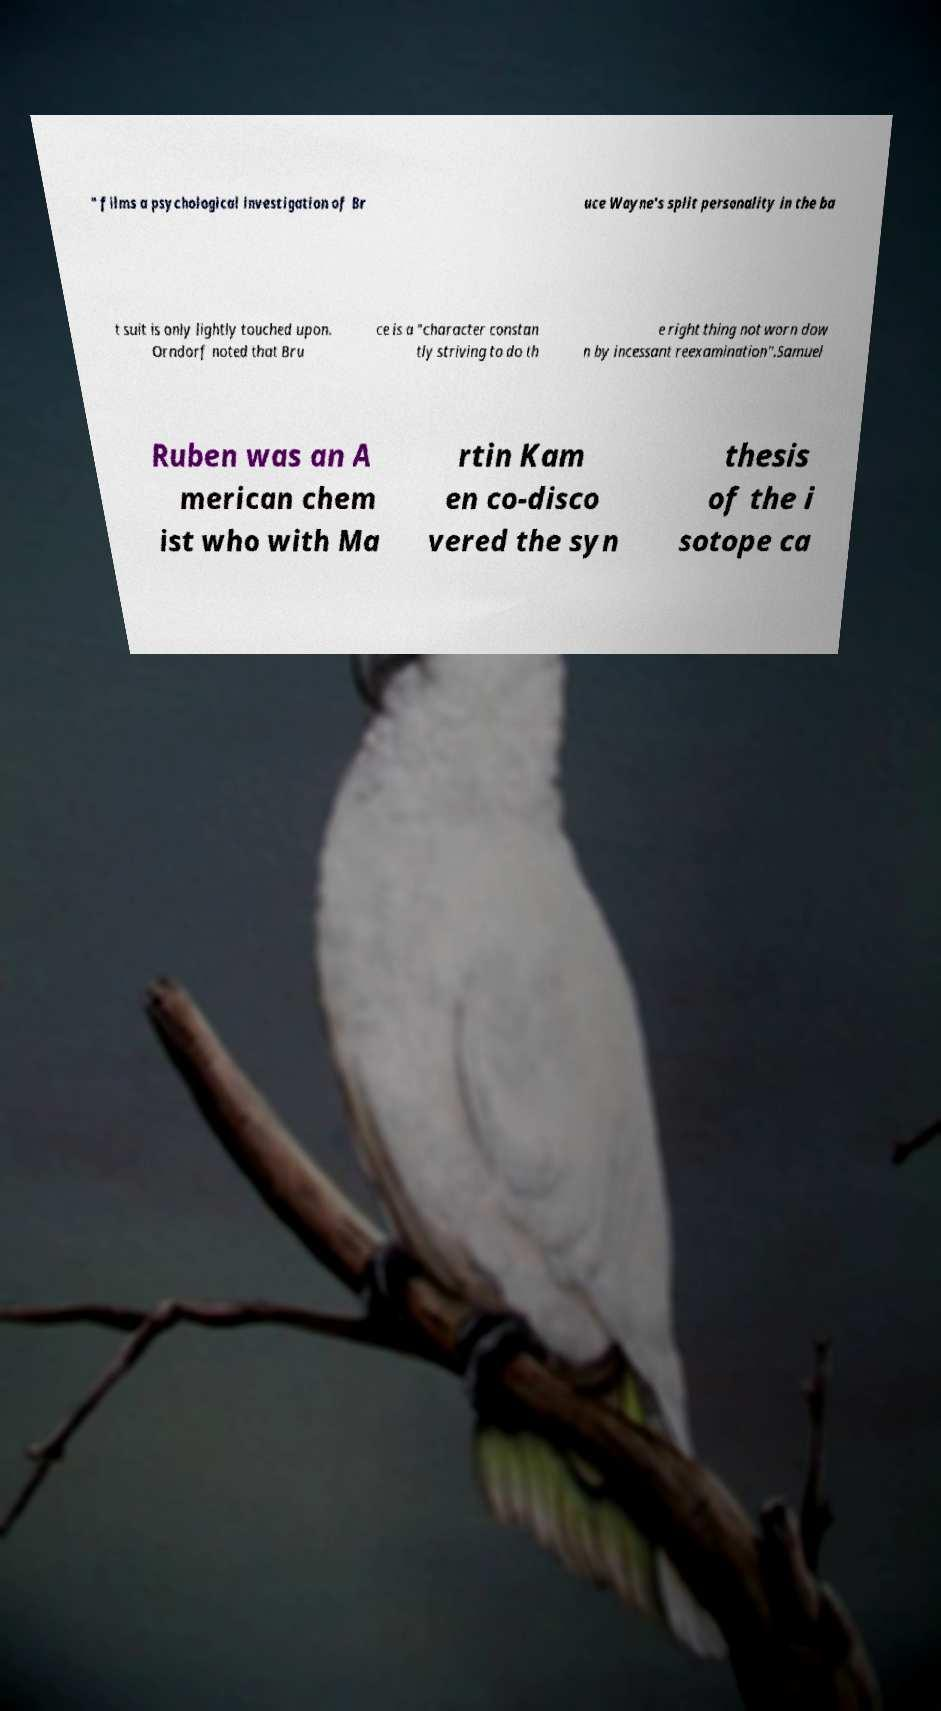Could you extract and type out the text from this image? " films a psychological investigation of Br uce Wayne's split personality in the ba t suit is only lightly touched upon. Orndorf noted that Bru ce is a "character constan tly striving to do th e right thing not worn dow n by incessant reexamination".Samuel Ruben was an A merican chem ist who with Ma rtin Kam en co-disco vered the syn thesis of the i sotope ca 